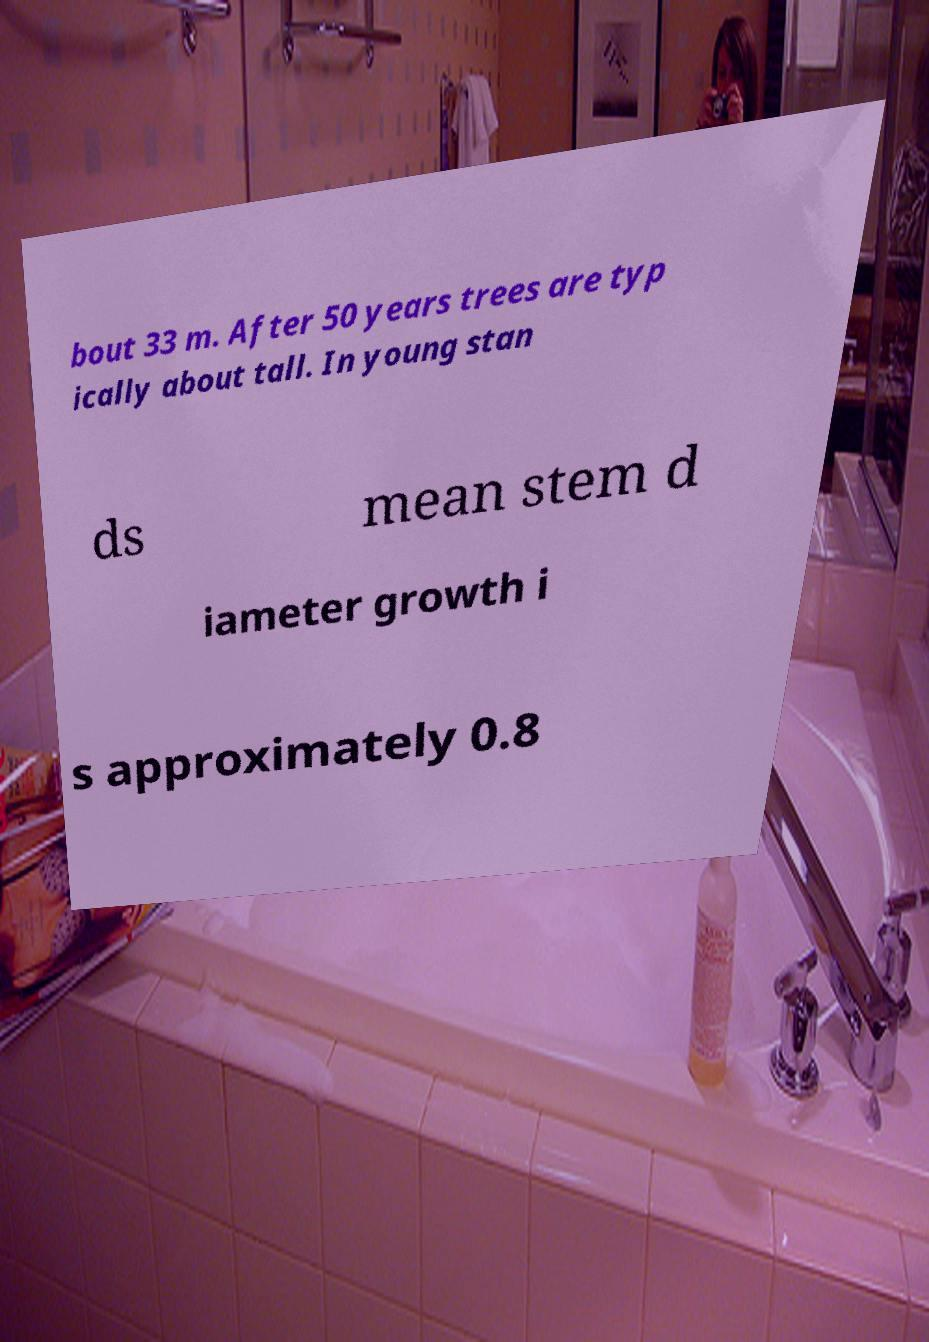Can you read and provide the text displayed in the image?This photo seems to have some interesting text. Can you extract and type it out for me? bout 33 m. After 50 years trees are typ ically about tall. In young stan ds mean stem d iameter growth i s approximately 0.8 